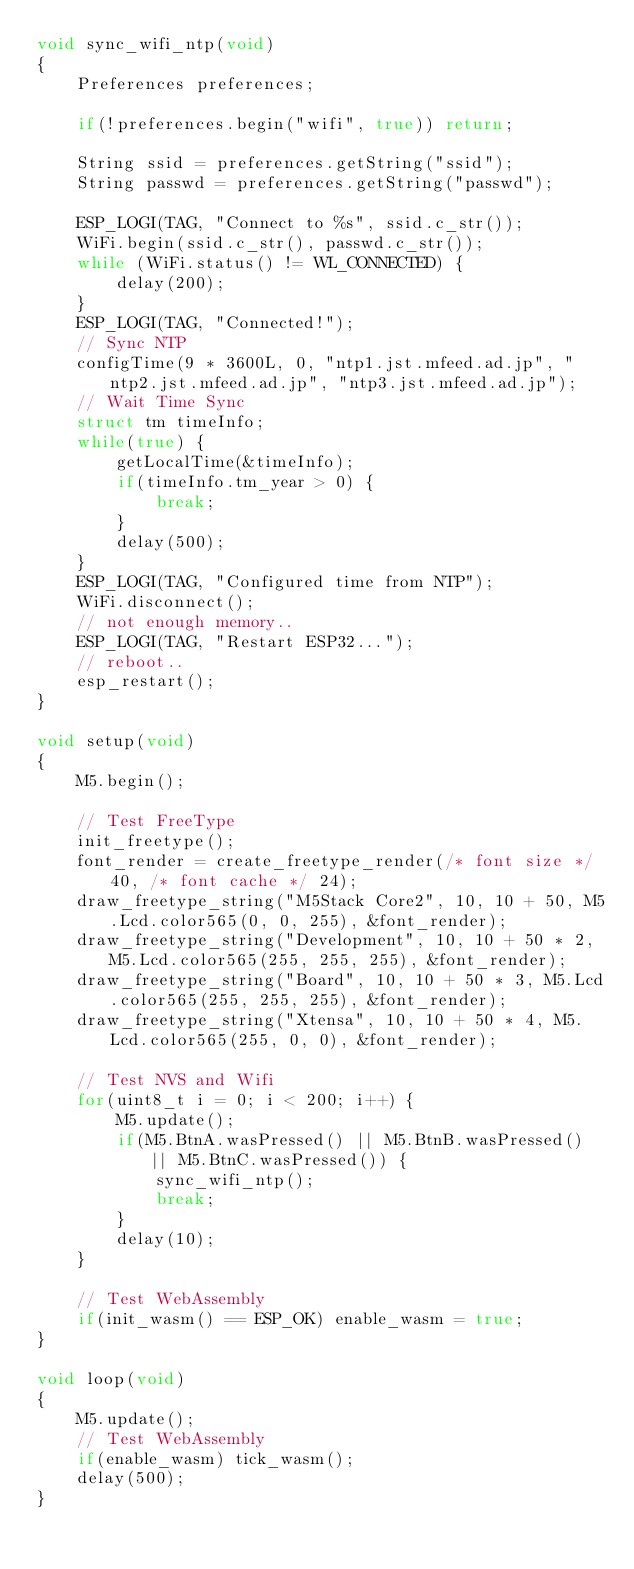<code> <loc_0><loc_0><loc_500><loc_500><_C++_>void sync_wifi_ntp(void)
{
    Preferences preferences;

    if(!preferences.begin("wifi", true)) return;

    String ssid = preferences.getString("ssid");
    String passwd = preferences.getString("passwd");

    ESP_LOGI(TAG, "Connect to %s", ssid.c_str());
    WiFi.begin(ssid.c_str(), passwd.c_str());
    while (WiFi.status() != WL_CONNECTED) {
        delay(200);
    }
    ESP_LOGI(TAG, "Connected!");
    // Sync NTP
    configTime(9 * 3600L, 0, "ntp1.jst.mfeed.ad.jp", "ntp2.jst.mfeed.ad.jp", "ntp3.jst.mfeed.ad.jp");
    // Wait Time Sync
    struct tm timeInfo;
    while(true) {
        getLocalTime(&timeInfo);
        if(timeInfo.tm_year > 0) {
            break;
        }
        delay(500);
    }
    ESP_LOGI(TAG, "Configured time from NTP");
    WiFi.disconnect();
    // not enough memory..
    ESP_LOGI(TAG, "Restart ESP32...");
    // reboot..
    esp_restart();
}

void setup(void)
{
    M5.begin();

    // Test FreeType
    init_freetype();
    font_render = create_freetype_render(/* font size */ 40, /* font cache */ 24);
    draw_freetype_string("M5Stack Core2", 10, 10 + 50, M5.Lcd.color565(0, 0, 255), &font_render);
    draw_freetype_string("Development", 10, 10 + 50 * 2, M5.Lcd.color565(255, 255, 255), &font_render);
    draw_freetype_string("Board", 10, 10 + 50 * 3, M5.Lcd.color565(255, 255, 255), &font_render);
    draw_freetype_string("Xtensa", 10, 10 + 50 * 4, M5.Lcd.color565(255, 0, 0), &font_render);

    // Test NVS and Wifi
    for(uint8_t i = 0; i < 200; i++) {
        M5.update();
        if(M5.BtnA.wasPressed() || M5.BtnB.wasPressed() || M5.BtnC.wasPressed()) {
            sync_wifi_ntp();
            break;
        }
        delay(10);
    }

    // Test WebAssembly
    if(init_wasm() == ESP_OK) enable_wasm = true;
}

void loop(void)
{
    M5.update();
    // Test WebAssembly
    if(enable_wasm) tick_wasm();
    delay(500);
}
</code> 